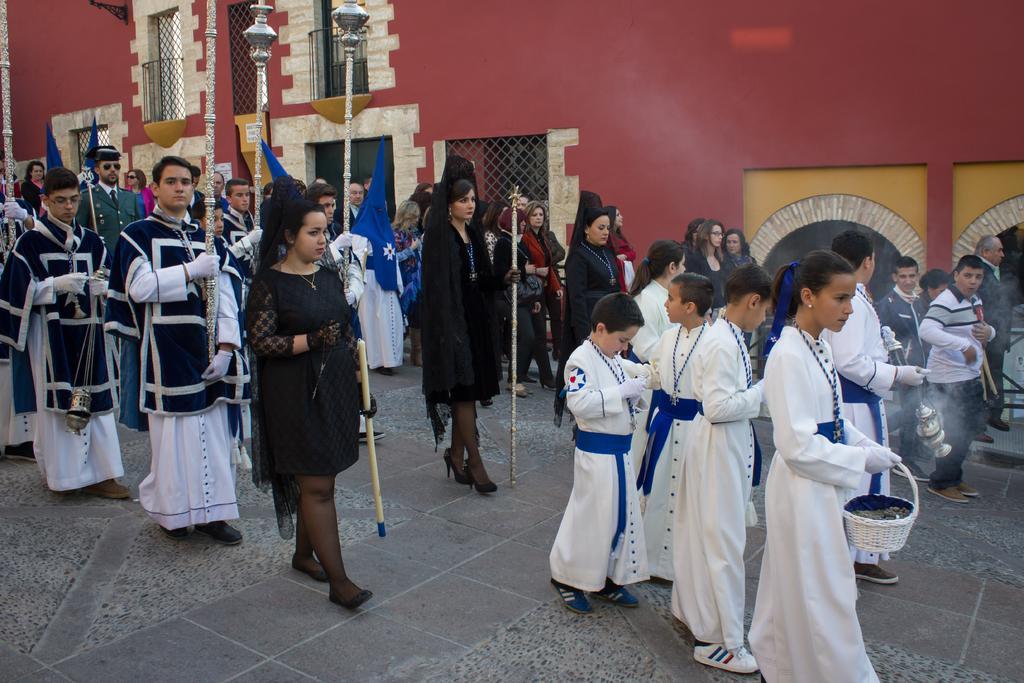Can you describe this image briefly? People are walking. The people at the front are wearing white dress and holding basket. The people at the back are holding sticks and person at the center is holding a blue flag. There is a building at the back which has windows and fencing. 